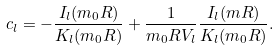Convert formula to latex. <formula><loc_0><loc_0><loc_500><loc_500>c _ { l } = - \frac { I _ { l } ( m _ { 0 } R ) } { K _ { l } ( m _ { 0 } R ) } + \frac { 1 } { m _ { 0 } R V _ { l } } \frac { I _ { l } ( m R ) } { K _ { l } ( m _ { 0 } R ) } .</formula> 